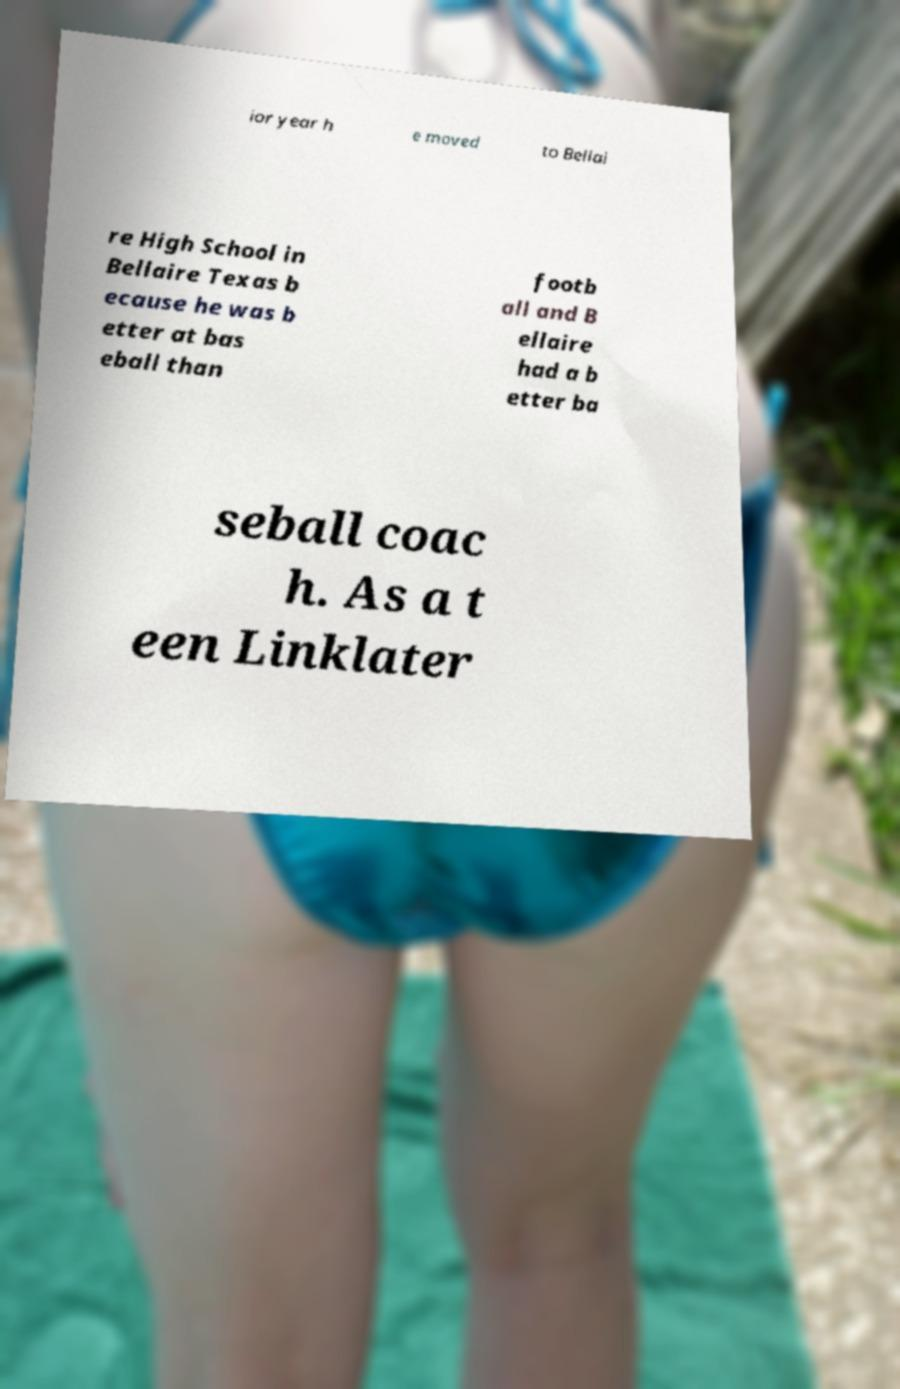Please identify and transcribe the text found in this image. ior year h e moved to Bellai re High School in Bellaire Texas b ecause he was b etter at bas eball than footb all and B ellaire had a b etter ba seball coac h. As a t een Linklater 